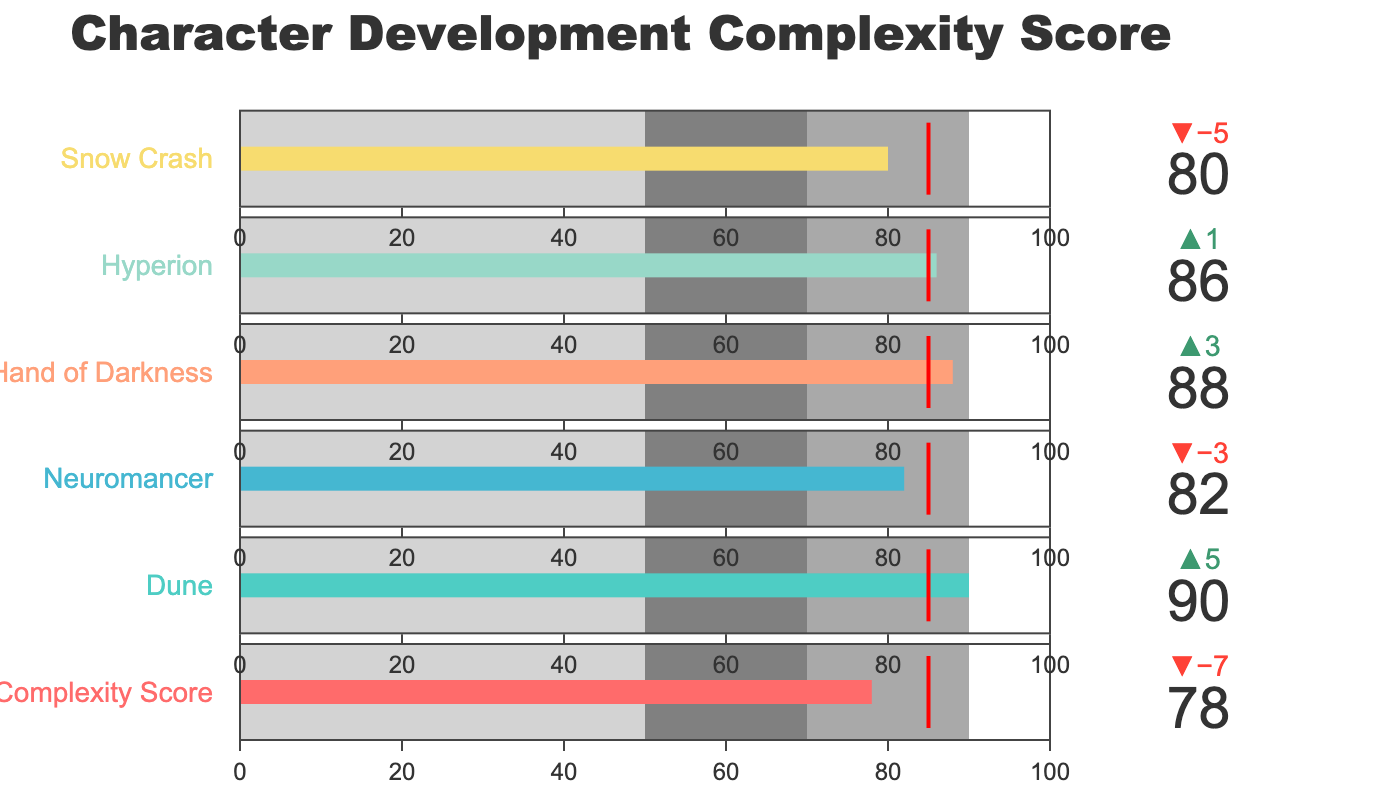What's the title of the chart? The title is typically located at the top of the chart and provides a succinct description of what the chart represents.
Answer: Character Development Complexity Score How does the character complexity score of your manuscript compare to the benchmark? The Bullet Chart uses a delta indicator to show the difference. For the manuscript, the actual score is 78, and the benchmark (reference) is 85. This difference is depicted by the delta value.
Answer: 78 is less than 85 Which novel has the highest character complexity score? By looking at the individual values on the chart, the score for "Dune" is the highest at 90.
Answer: Dune What color represents the character complexity score for "Snow Crash"? Identify the specific color bar used for "Snow Crash" within the chart.
Answer: Light orange (#FFA07A) Which novels have complexity scores above the comparative benchmark? Compare the actual scores of each novel to the comparative benchmark of 85 and list those higher than 85.
Answer: Dune, The Left Hand of Darkness, Hyperion What's the range for average character complexity? The range for 'average' character complexity is typically indicated by one of the steps in the bullet chart. Here, it goes from 50 to 70.
Answer: 50 to 70 If your manuscript's score increased by 10 points, would it surpass the comparative benchmark? Adding 10 points to your manuscript's score of 78 gives 88, which is compared to the benchmark of 85.
Answer: Yes How many novels have worse scores compared to your manuscript? Compare each novel's score with your manuscript's score of 78 to find those with lesser values.
Answer: 0 What is the color used to represent the 'poor' range of complexity? The 'poor' range is the second step on the Bullet Chart and is represented by the light gray color.
Answer: Light gray How does "Neuromancer" perform relative to the benchmark? Neuromancer's actual score is 82 compared to the benchmark of 85. The difference shows it is slightly below the benchmark.
Answer: Less than the benchmark by 3 